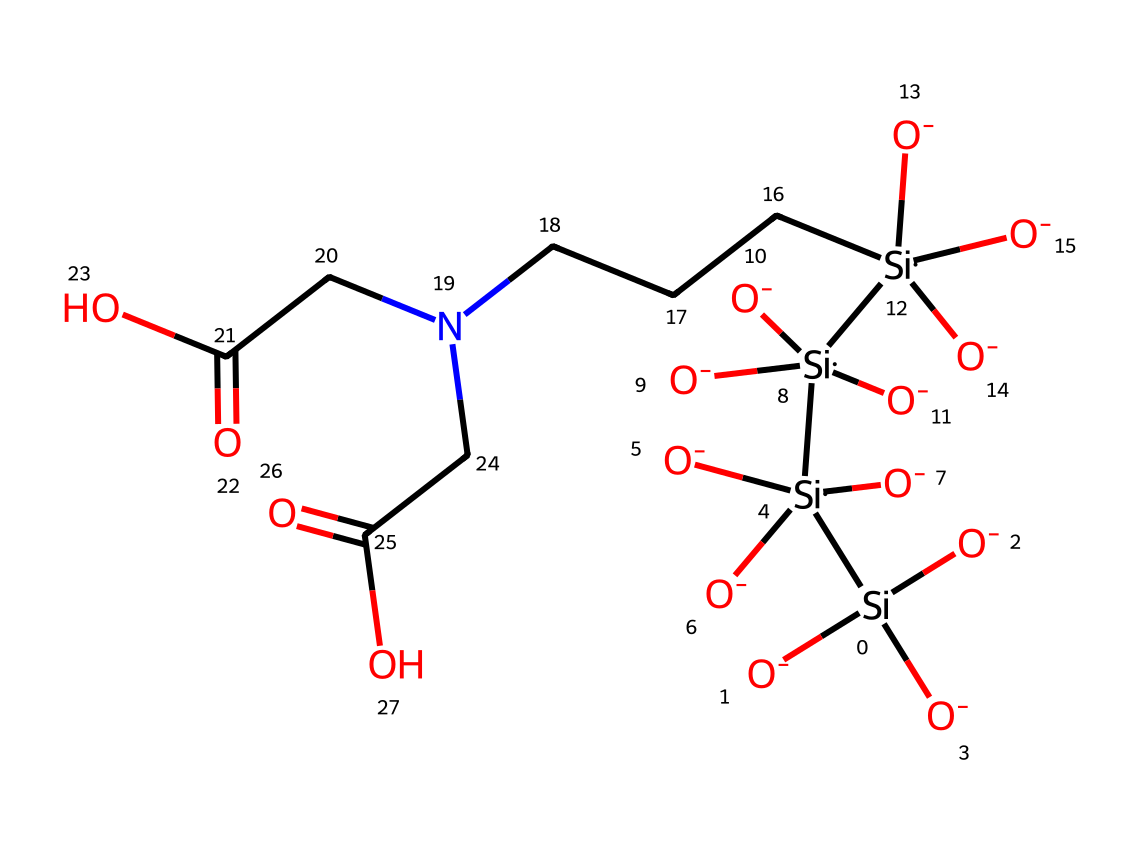what is the main elemental component of this chemical? The chemical structure displays silicon atoms as the primary elements, indicated by the presence of [Si] in the SMILES representation.
Answer: silicon how many silicon atoms are present in this chemical? The SMILES notation shows four instances of the silicon atom [Si], indicating that there are four silicon atoms in total within the structure.
Answer: four what functional groups are present in this chemical? The chemical contains carboxylic acid groups, indicated by the presence of the -COOH functionality in the structure, seen at the end of the SMILES representation (CC(=O)O).
Answer: carboxylic acid which properties might make this chemical suitable for biomedical imaging? The surface functionalization with carboxylic acid groups enhances water solubility and biocompatibility, which are crucial properties for effective biomedical imaging applications.
Answer: water solubility and biocompatibility does this chemical structure contain any nitrogen? The structure includes a nitrogen atom, shown within the amine group (NCC), indicating its presence in the chemical.
Answer: yes what type of quantum dots does this chemical represent? Given its silicon composition and surface functionalization with biomolecules, this chemical represents silicon quantum dots specifically used for biomedical applications.
Answer: silicon quantum dots 